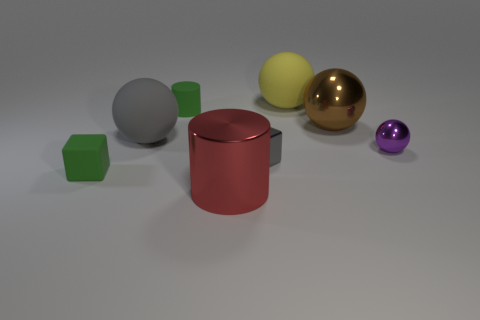The small block behind the cube to the left of the large cylinder that is in front of the tiny green rubber block is made of what material? The small block situated behind the mid-sized cube and to the left of the larger red cylinder, which in turn is positioned in front of a tiny green rubber block, appears to be made of a metallic material given its reflective surface and sheen. 